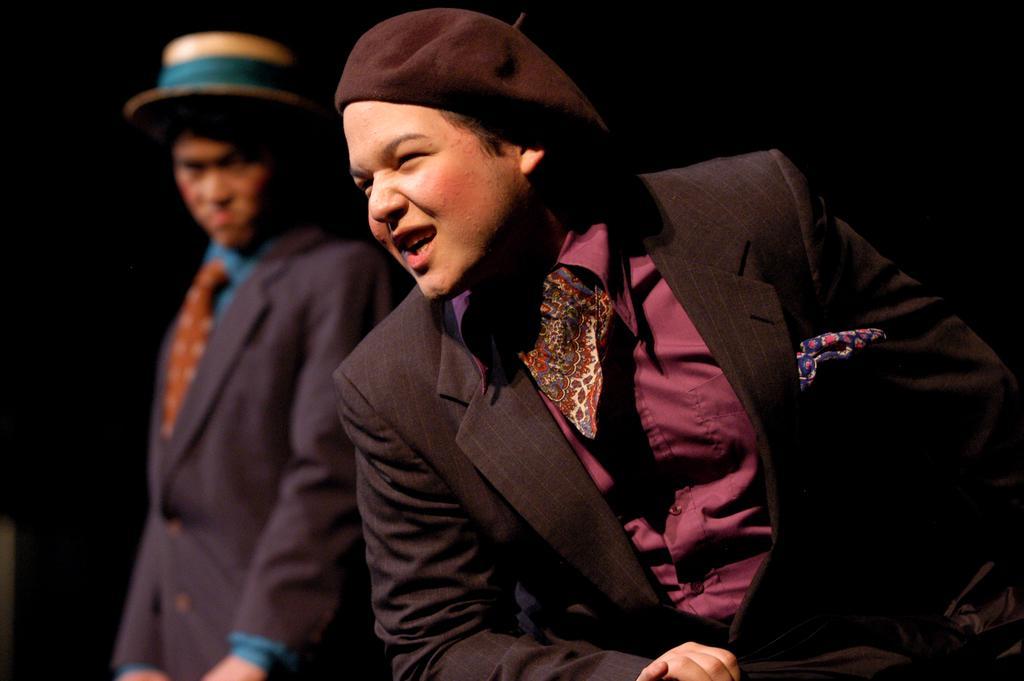Can you describe this image briefly? In this image, we can see two people in a suit. They are wearing cap and hat. Here a person is smiling and seeing on left side. 